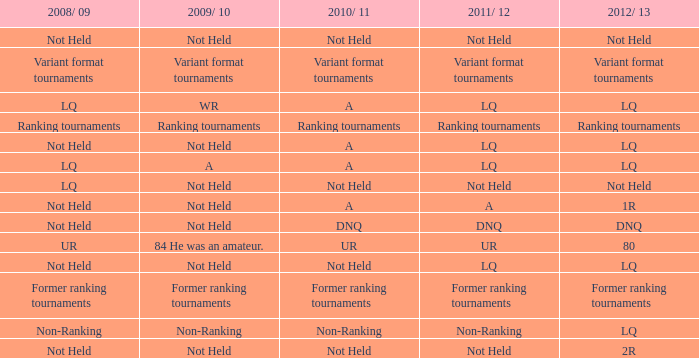What 2010/ 11 has not held as 2009/ 10, and 1r as the 2012/ 13? A. 